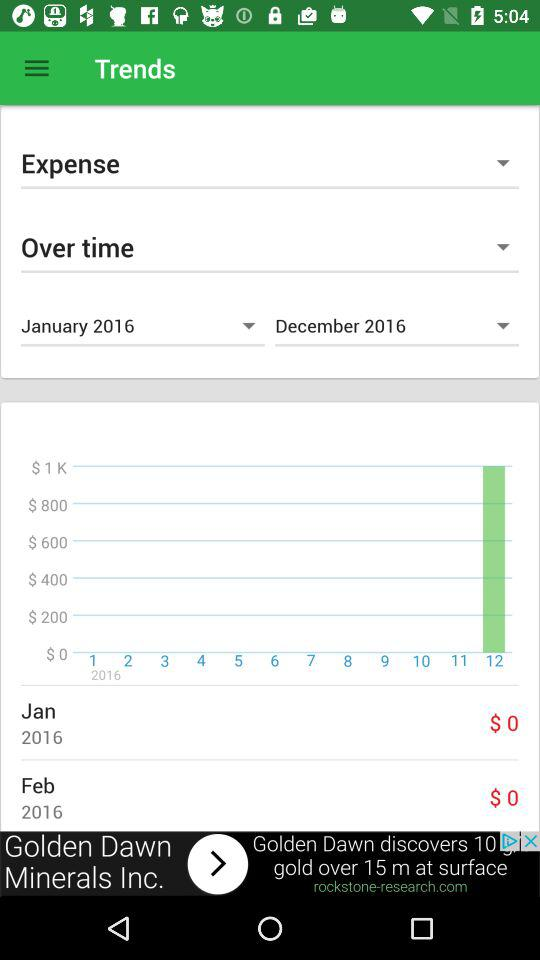What is the expense in January 2016? The expense in January 2016 is $0. 